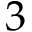Convert formula to latex. <formula><loc_0><loc_0><loc_500><loc_500>3</formula> 